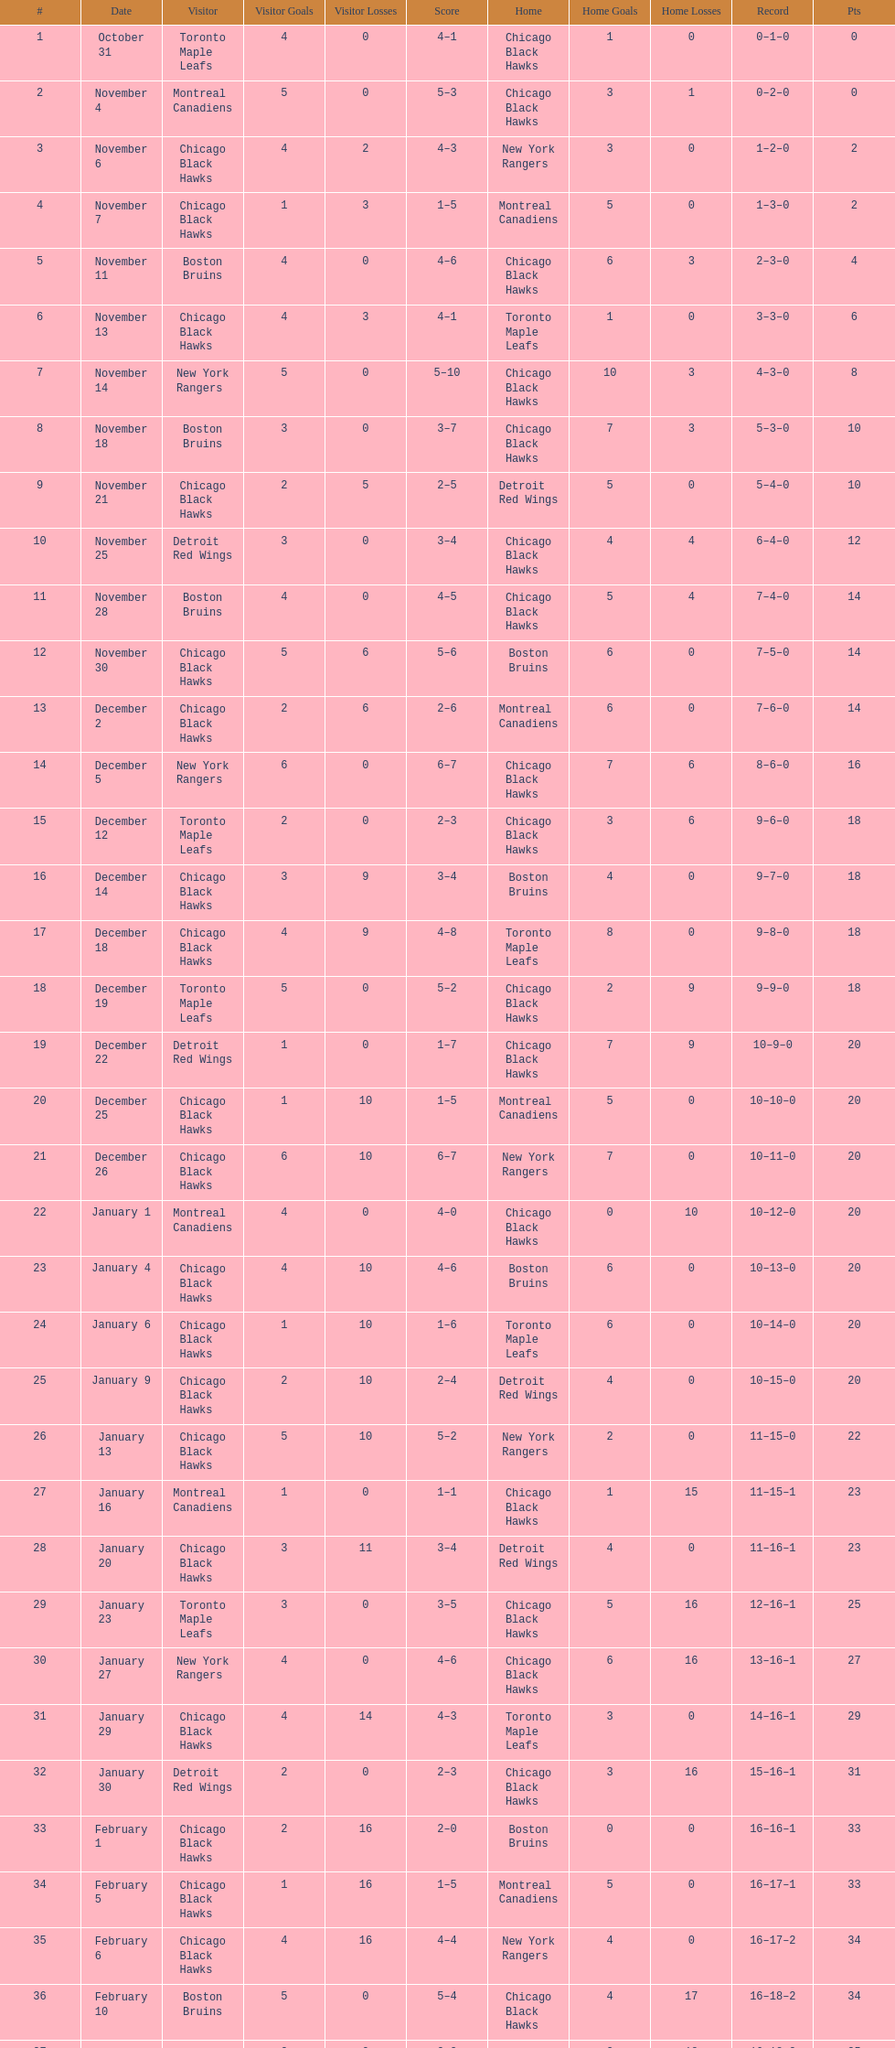Which team was the earliest one the black hawks got beaten by? Toronto Maple Leafs. 